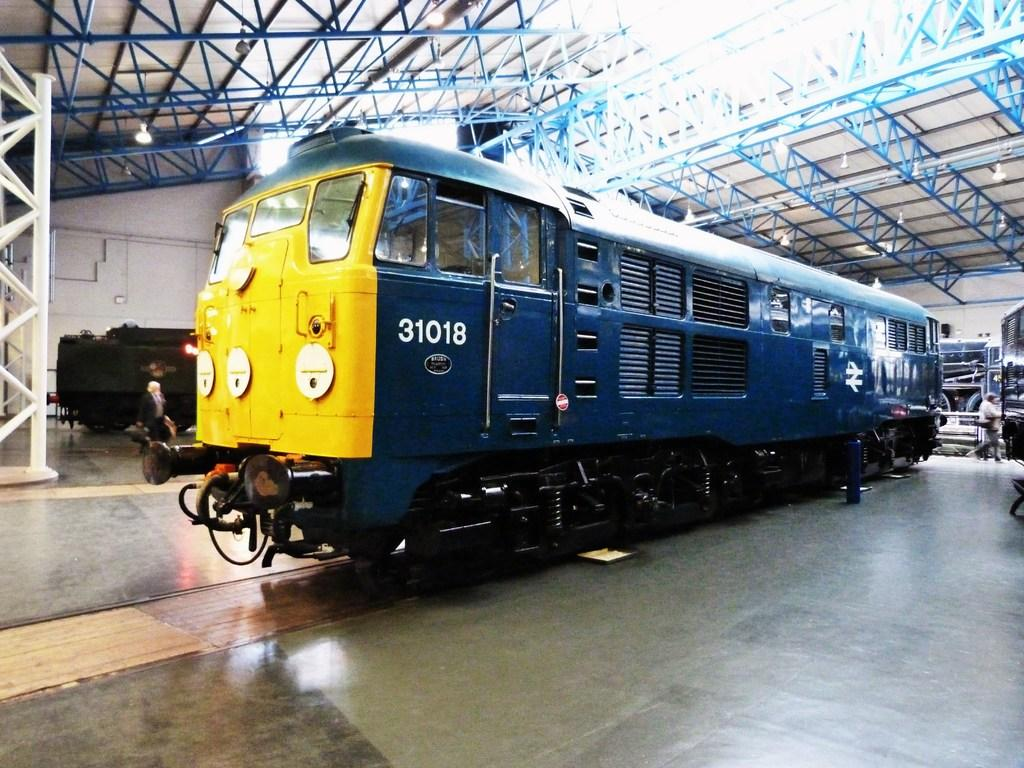Provide a one-sentence caption for the provided image. Blue and yellow Train engine 31018 sits inside a building. 